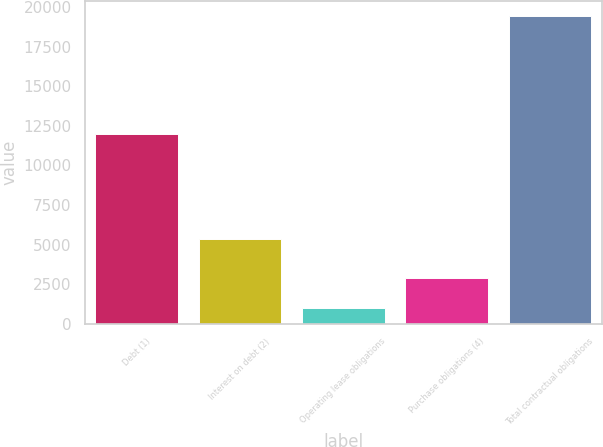Convert chart to OTSL. <chart><loc_0><loc_0><loc_500><loc_500><bar_chart><fcel>Debt (1)<fcel>Interest on debt (2)<fcel>Operating lease obligations<fcel>Purchase obligations (4)<fcel>Total contractual obligations<nl><fcel>11955.3<fcel>5368.8<fcel>1025.3<fcel>2863.95<fcel>19411.8<nl></chart> 